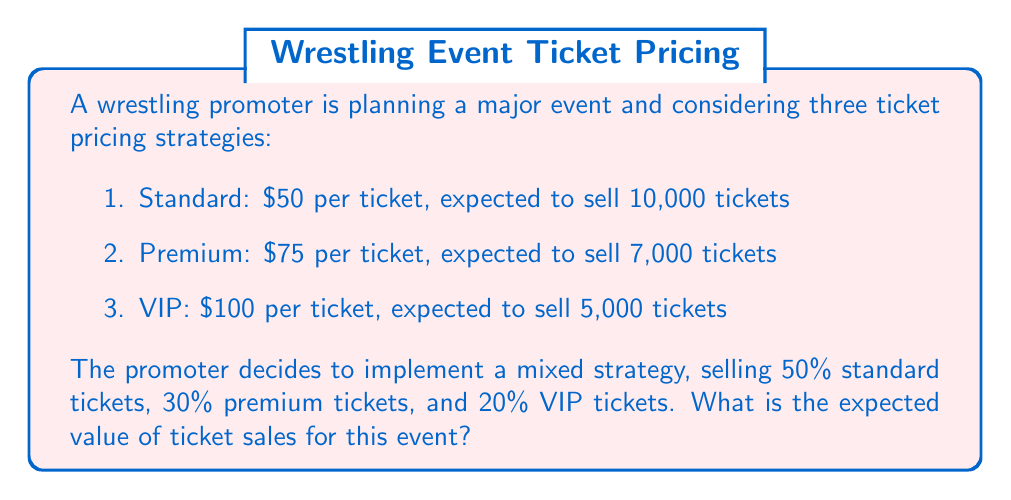Help me with this question. Let's approach this step-by-step:

1. Calculate the expected revenue for each ticket type:

   Standard: $50 * 10,000 = $500,000
   Premium: $75 * 7,000 = $525,000
   VIP: $100 * 5,000 = $500,000

2. Calculate the proportion of each ticket type sold:

   Standard: 50% = 0.5
   Premium: 30% = 0.3
   VIP: 20% = 0.2

3. Calculate the expected value for each ticket type:

   Standard: $500,000 * 0.5 = $250,000
   Premium: $525,000 * 0.3 = $157,500
   VIP: $500,000 * 0.2 = $100,000

4. Sum up the expected values:

   Total Expected Value = $250,000 + $157,500 + $100,000 = $507,500

The formula for this calculation can be expressed as:

$$E(X) = \sum_{i=1}^{n} p_i x_i$$

Where:
$E(X)$ is the expected value
$p_i$ is the probability (proportion) of each ticket type
$x_i$ is the revenue from each ticket type

Substituting our values:

$$E(X) = (0.5 * 500000) + (0.3 * 525000) + (0.2 * 500000) = 507500$$
Answer: $507,500 